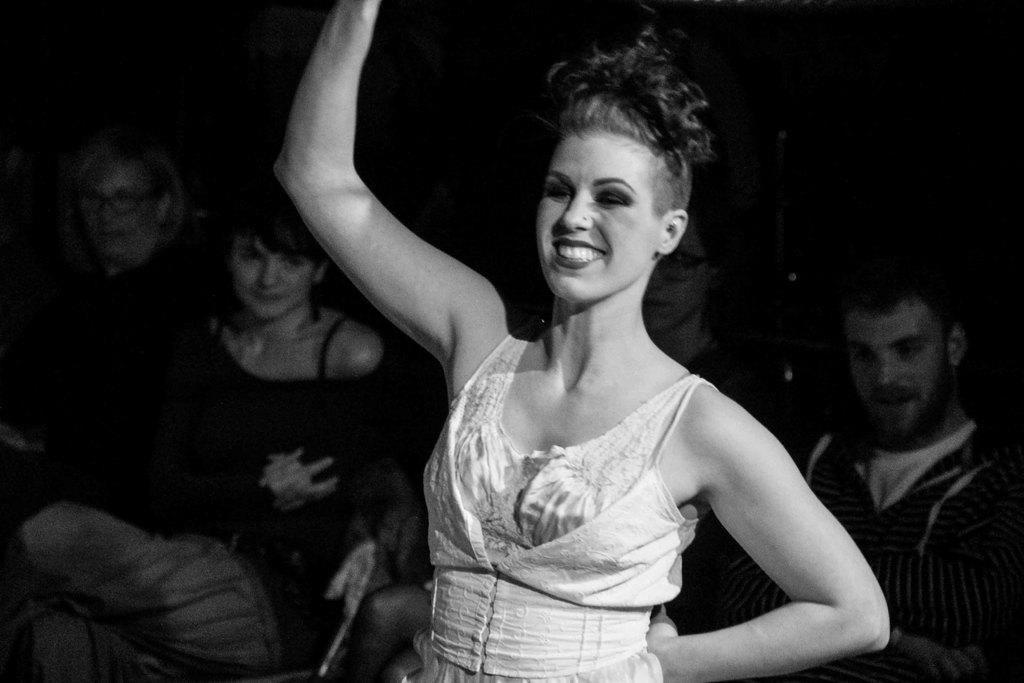What is the main subject of the image? The main subject of the image is a group of people. What are the people in the image wearing? The people in the image are wearing dresses. Can you identify any specific accessory worn by one of the people? Yes, one person in the group is wearing specs. What is the color scheme of the image? The image is black and white. What type of orange can be seen in the hands of the people in the image? There is no orange present in the image; the people are wearing dresses and one person is wearing specs. What kind of protest is being depicted in the image? There is no protest depicted in the image; it features a group of people wearing dresses, with one person wearing specs. 